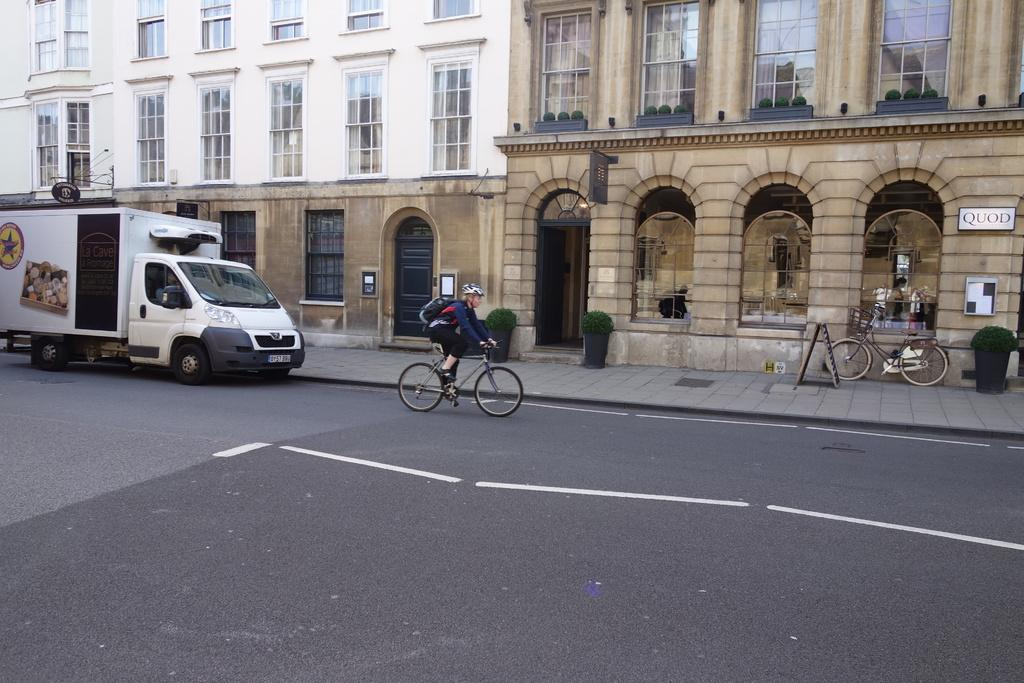What is: What is the person in the image doing? The person in the image is riding a bicycle. What type of path is the person riding on? This is a road. What other mode of transportation is present in the image? There is a vehicle in the image. What is the main subject of the image? There is a bicycle in the image. What type of vegetation can be seen in the image? There are plants in the image. What objects are made of wood in the image? There are boards in the image. What objects might the person be using? There are glasses in the image. What can be seen in the background of the image? There is a building in the background of the image. How many trees are visible in the image? There are no trees visible in the image. 